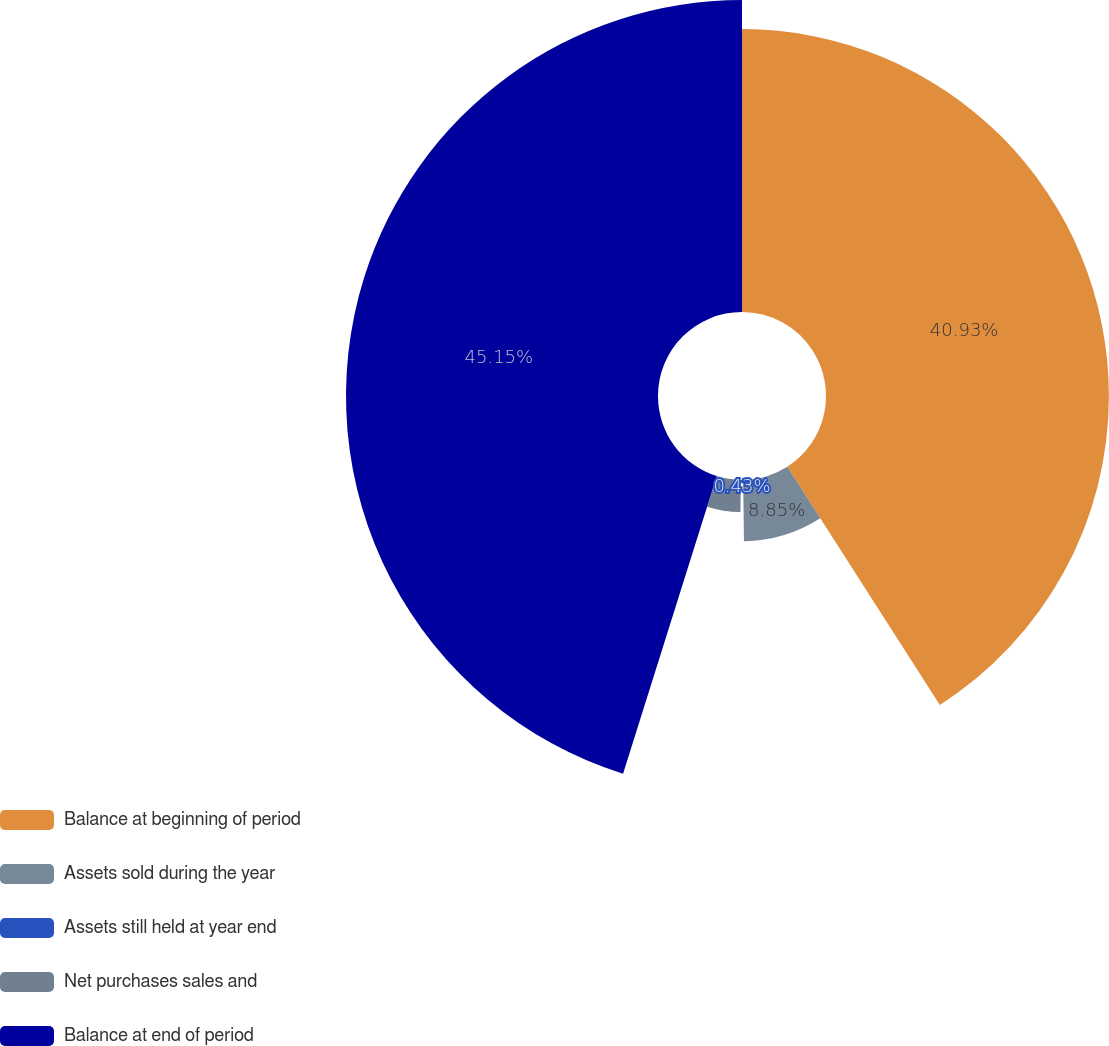Convert chart to OTSL. <chart><loc_0><loc_0><loc_500><loc_500><pie_chart><fcel>Balance at beginning of period<fcel>Assets sold during the year<fcel>Assets still held at year end<fcel>Net purchases sales and<fcel>Balance at end of period<nl><fcel>40.93%<fcel>8.85%<fcel>0.43%<fcel>4.64%<fcel>45.14%<nl></chart> 